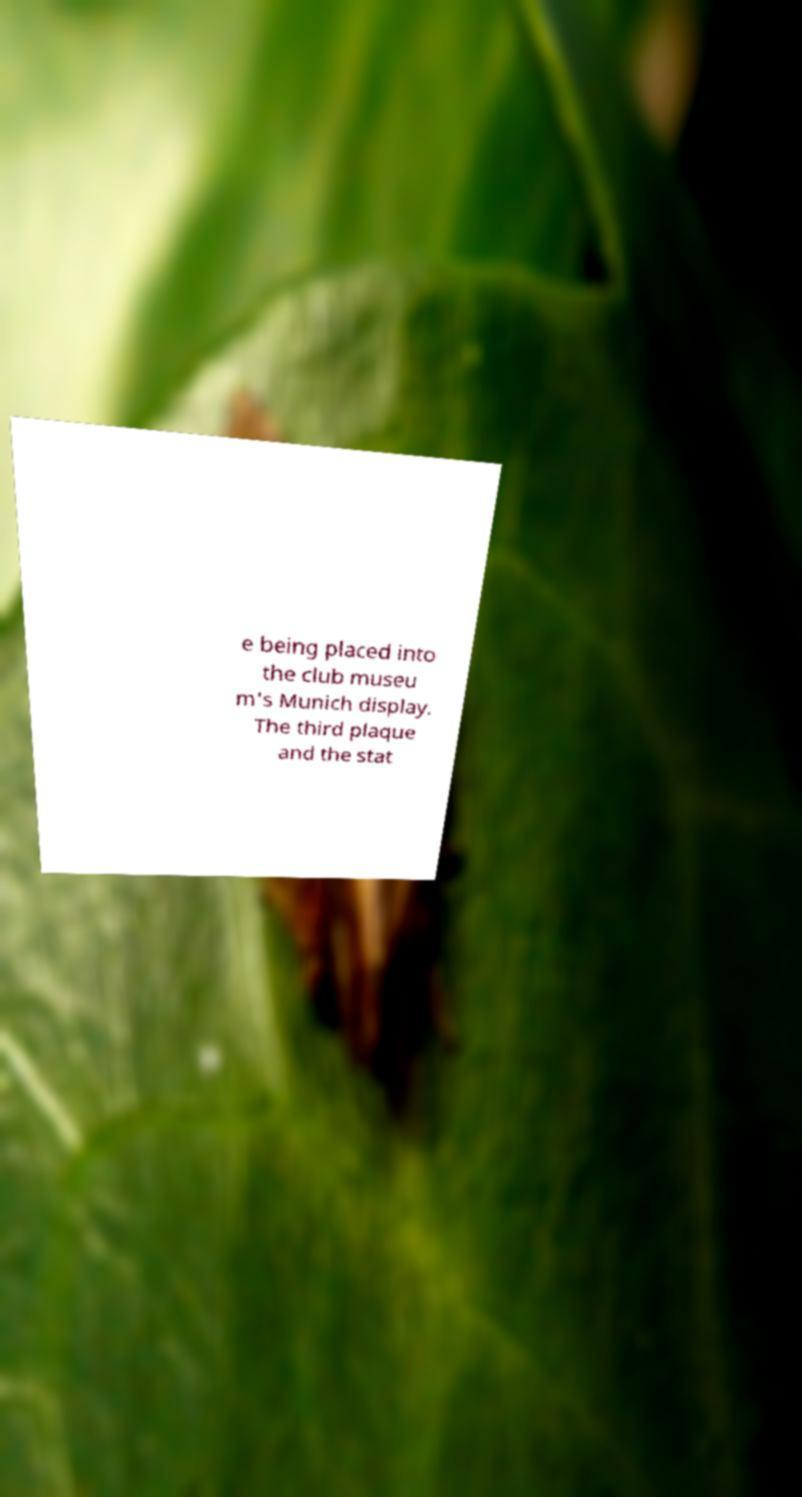I need the written content from this picture converted into text. Can you do that? e being placed into the club museu m's Munich display. The third plaque and the stat 